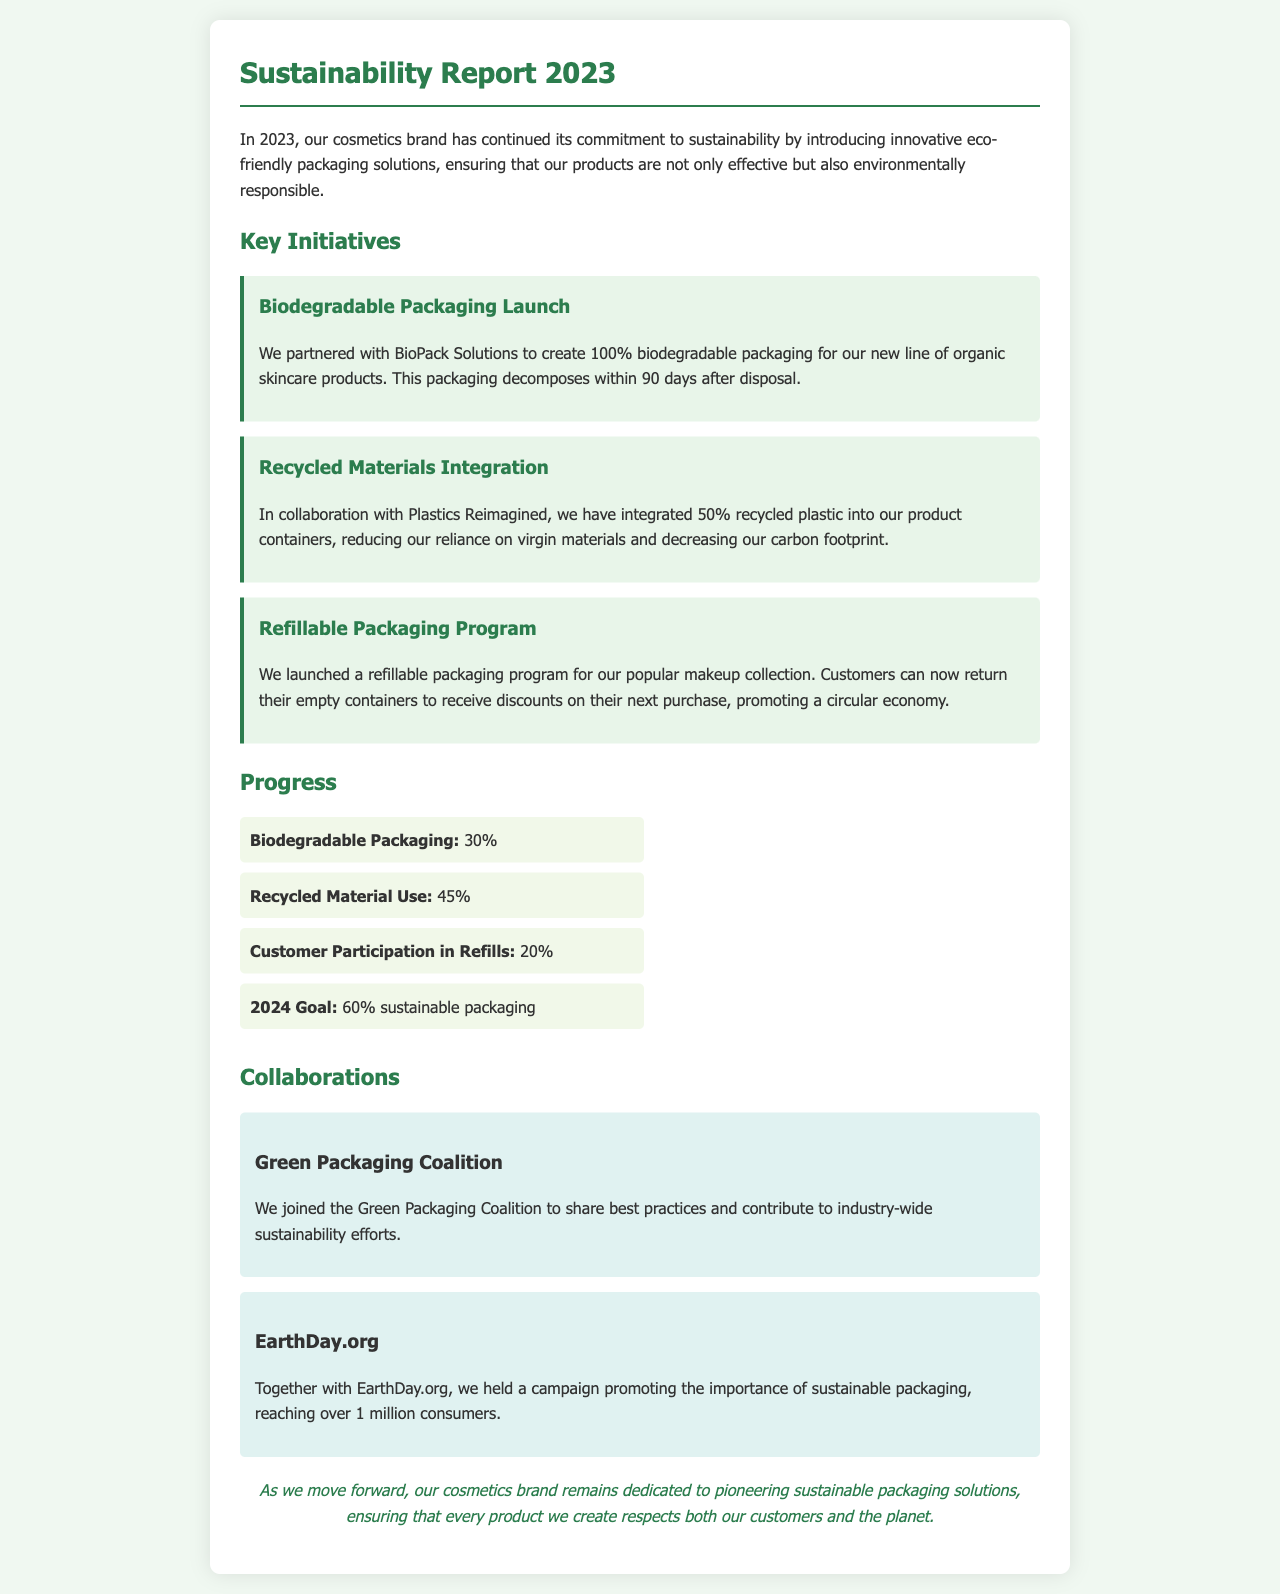what is the name of the partnership for biodegradable packaging? The partnership for biodegradable packaging is with BioPack Solutions.
Answer: BioPack Solutions what percentage of recycled plastic is integrated into the product containers? The document states that 50% recycled plastic has been integrated into the product containers.
Answer: 50% what is the customer participation percentage in the refillable program? The document mentions that customer participation in refills is at 20%.
Answer: 20% what is the goal for sustainable packaging in 2024? According to the document, the goal for sustainable packaging in 2024 is 60%.
Answer: 60% which coalition was joined for sustainability efforts? The document states the Green Packaging Coalition was joined for sustainability efforts.
Answer: Green Packaging Coalition how many consumers were reached in the campaign with EarthDay.org? The campaign with EarthDay.org reached over 1 million consumers.
Answer: over 1 million what type of packaging is being launched for the organic skincare products? The document indicates that 100% biodegradable packaging is being launched for the organic skincare products.
Answer: 100% biodegradable which initiative helps promote a circular economy? The refillable packaging program helps promote a circular economy.
Answer: refillable packaging program what background color is used for the initiatives section? The background color used for the initiatives section is light green.
Answer: light green 